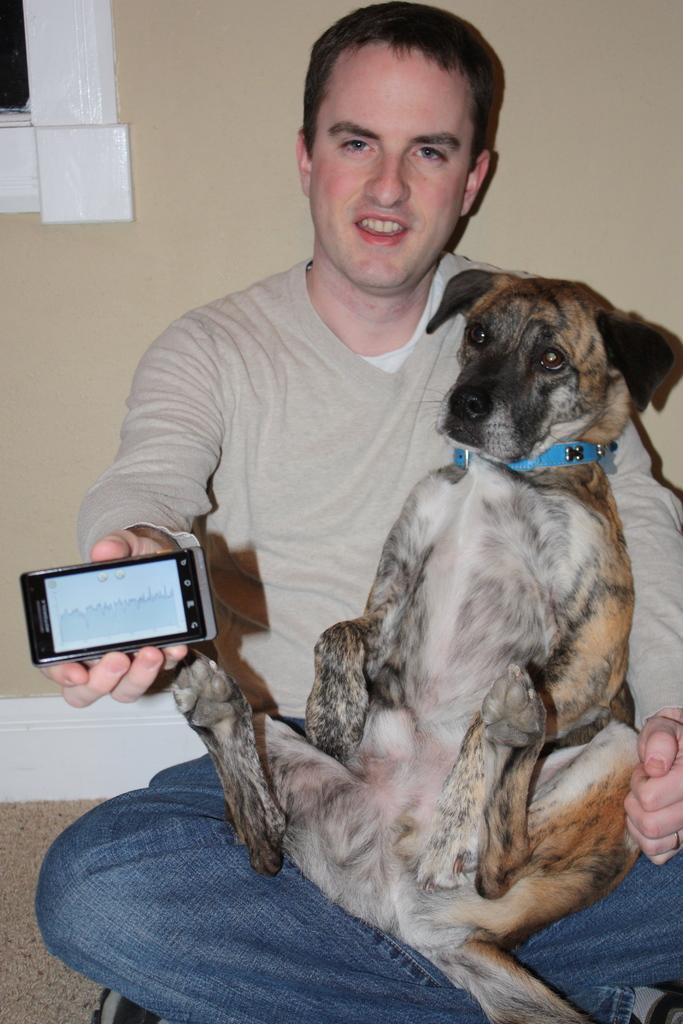Describe this image in one or two sentences. In the middle of the image a man is sitting, smiling and he is holding a dog and mobile phone. Behind him we can see a wall. 